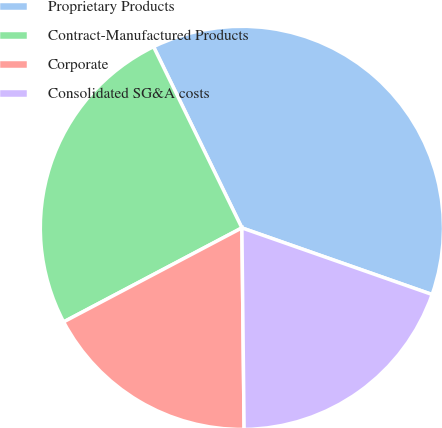<chart> <loc_0><loc_0><loc_500><loc_500><pie_chart><fcel>Proprietary Products<fcel>Contract-Manufactured Products<fcel>Corporate<fcel>Consolidated SG&A costs<nl><fcel>37.58%<fcel>25.5%<fcel>17.45%<fcel>19.46%<nl></chart> 